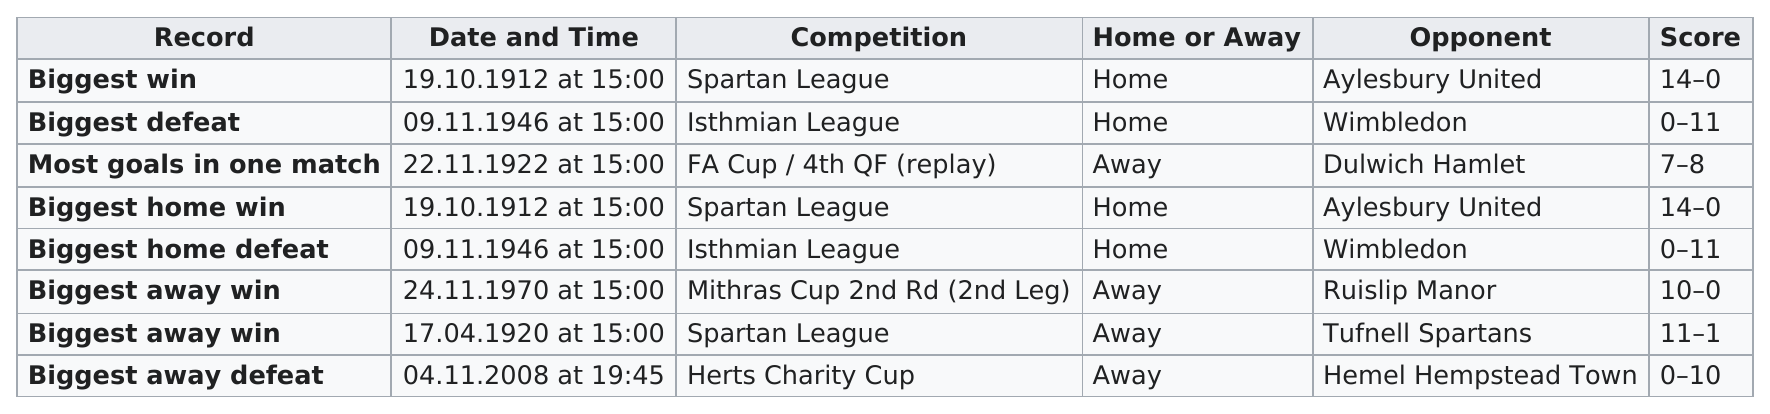Indicate a few pertinent items in this graphic. The two largest score differences were from competition against the Spartan League. The difference in score between the two teams that participated in the April 17, 1920 game was 10. In total, there were four home games. There are two games in the records that occurred before 1920. Out of the total number of competitions that were held, how many had a difference in score that was greater than 5? 